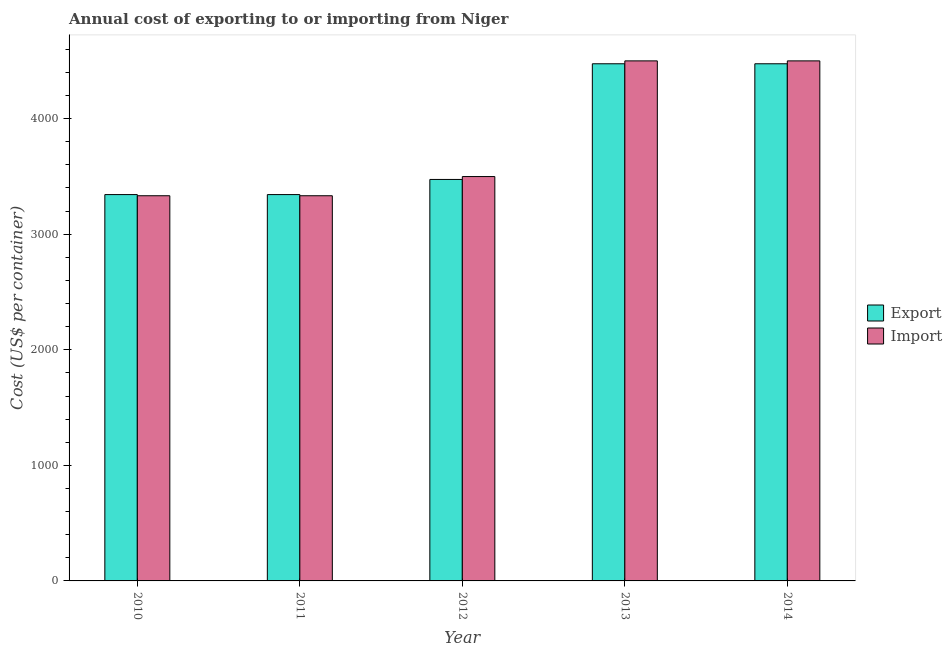How many groups of bars are there?
Provide a short and direct response. 5. How many bars are there on the 4th tick from the left?
Offer a terse response. 2. What is the label of the 5th group of bars from the left?
Your response must be concise. 2014. What is the import cost in 2012?
Offer a very short reply. 3499. Across all years, what is the maximum import cost?
Your answer should be very brief. 4500. Across all years, what is the minimum export cost?
Ensure brevity in your answer.  3343. In which year was the export cost maximum?
Ensure brevity in your answer.  2013. What is the total export cost in the graph?
Your response must be concise. 1.91e+04. What is the difference between the import cost in 2010 and that in 2013?
Provide a succinct answer. -1167. What is the difference between the export cost in 2012 and the import cost in 2011?
Your answer should be compact. 131. What is the average import cost per year?
Give a very brief answer. 3833. What is the ratio of the import cost in 2010 to that in 2014?
Your answer should be very brief. 0.74. Is the export cost in 2010 less than that in 2011?
Give a very brief answer. No. Is the difference between the import cost in 2011 and 2013 greater than the difference between the export cost in 2011 and 2013?
Your answer should be very brief. No. What is the difference between the highest and the lowest export cost?
Your answer should be compact. 1132. Is the sum of the import cost in 2010 and 2014 greater than the maximum export cost across all years?
Your answer should be very brief. Yes. What does the 1st bar from the left in 2010 represents?
Your answer should be very brief. Export. What does the 1st bar from the right in 2013 represents?
Keep it short and to the point. Import. How many bars are there?
Offer a terse response. 10. Are all the bars in the graph horizontal?
Give a very brief answer. No. Are the values on the major ticks of Y-axis written in scientific E-notation?
Provide a short and direct response. No. Does the graph contain any zero values?
Ensure brevity in your answer.  No. Does the graph contain grids?
Your answer should be compact. No. How many legend labels are there?
Your response must be concise. 2. What is the title of the graph?
Your answer should be compact. Annual cost of exporting to or importing from Niger. Does "Current US$" appear as one of the legend labels in the graph?
Ensure brevity in your answer.  No. What is the label or title of the X-axis?
Ensure brevity in your answer.  Year. What is the label or title of the Y-axis?
Provide a succinct answer. Cost (US$ per container). What is the Cost (US$ per container) in Export in 2010?
Give a very brief answer. 3343. What is the Cost (US$ per container) in Import in 2010?
Provide a succinct answer. 3333. What is the Cost (US$ per container) of Export in 2011?
Provide a succinct answer. 3343. What is the Cost (US$ per container) in Import in 2011?
Your answer should be compact. 3333. What is the Cost (US$ per container) of Export in 2012?
Offer a terse response. 3474. What is the Cost (US$ per container) in Import in 2012?
Offer a very short reply. 3499. What is the Cost (US$ per container) in Export in 2013?
Provide a short and direct response. 4475. What is the Cost (US$ per container) of Import in 2013?
Your answer should be very brief. 4500. What is the Cost (US$ per container) in Export in 2014?
Offer a terse response. 4475. What is the Cost (US$ per container) in Import in 2014?
Offer a terse response. 4500. Across all years, what is the maximum Cost (US$ per container) of Export?
Provide a short and direct response. 4475. Across all years, what is the maximum Cost (US$ per container) in Import?
Provide a short and direct response. 4500. Across all years, what is the minimum Cost (US$ per container) of Export?
Make the answer very short. 3343. Across all years, what is the minimum Cost (US$ per container) in Import?
Provide a succinct answer. 3333. What is the total Cost (US$ per container) of Export in the graph?
Keep it short and to the point. 1.91e+04. What is the total Cost (US$ per container) in Import in the graph?
Your answer should be very brief. 1.92e+04. What is the difference between the Cost (US$ per container) of Export in 2010 and that in 2011?
Make the answer very short. 0. What is the difference between the Cost (US$ per container) of Import in 2010 and that in 2011?
Your answer should be very brief. 0. What is the difference between the Cost (US$ per container) of Export in 2010 and that in 2012?
Keep it short and to the point. -131. What is the difference between the Cost (US$ per container) in Import in 2010 and that in 2012?
Provide a short and direct response. -166. What is the difference between the Cost (US$ per container) in Export in 2010 and that in 2013?
Offer a terse response. -1132. What is the difference between the Cost (US$ per container) of Import in 2010 and that in 2013?
Ensure brevity in your answer.  -1167. What is the difference between the Cost (US$ per container) of Export in 2010 and that in 2014?
Offer a terse response. -1132. What is the difference between the Cost (US$ per container) of Import in 2010 and that in 2014?
Your answer should be very brief. -1167. What is the difference between the Cost (US$ per container) of Export in 2011 and that in 2012?
Provide a short and direct response. -131. What is the difference between the Cost (US$ per container) of Import in 2011 and that in 2012?
Your answer should be very brief. -166. What is the difference between the Cost (US$ per container) of Export in 2011 and that in 2013?
Keep it short and to the point. -1132. What is the difference between the Cost (US$ per container) in Import in 2011 and that in 2013?
Your response must be concise. -1167. What is the difference between the Cost (US$ per container) in Export in 2011 and that in 2014?
Offer a very short reply. -1132. What is the difference between the Cost (US$ per container) in Import in 2011 and that in 2014?
Provide a short and direct response. -1167. What is the difference between the Cost (US$ per container) in Export in 2012 and that in 2013?
Offer a very short reply. -1001. What is the difference between the Cost (US$ per container) in Import in 2012 and that in 2013?
Your answer should be very brief. -1001. What is the difference between the Cost (US$ per container) of Export in 2012 and that in 2014?
Your answer should be very brief. -1001. What is the difference between the Cost (US$ per container) of Import in 2012 and that in 2014?
Keep it short and to the point. -1001. What is the difference between the Cost (US$ per container) of Export in 2013 and that in 2014?
Keep it short and to the point. 0. What is the difference between the Cost (US$ per container) in Export in 2010 and the Cost (US$ per container) in Import in 2012?
Your answer should be very brief. -156. What is the difference between the Cost (US$ per container) in Export in 2010 and the Cost (US$ per container) in Import in 2013?
Your answer should be compact. -1157. What is the difference between the Cost (US$ per container) in Export in 2010 and the Cost (US$ per container) in Import in 2014?
Make the answer very short. -1157. What is the difference between the Cost (US$ per container) in Export in 2011 and the Cost (US$ per container) in Import in 2012?
Your answer should be very brief. -156. What is the difference between the Cost (US$ per container) in Export in 2011 and the Cost (US$ per container) in Import in 2013?
Give a very brief answer. -1157. What is the difference between the Cost (US$ per container) in Export in 2011 and the Cost (US$ per container) in Import in 2014?
Ensure brevity in your answer.  -1157. What is the difference between the Cost (US$ per container) of Export in 2012 and the Cost (US$ per container) of Import in 2013?
Your answer should be very brief. -1026. What is the difference between the Cost (US$ per container) in Export in 2012 and the Cost (US$ per container) in Import in 2014?
Your response must be concise. -1026. What is the average Cost (US$ per container) in Export per year?
Your answer should be very brief. 3822. What is the average Cost (US$ per container) in Import per year?
Ensure brevity in your answer.  3833. In the year 2010, what is the difference between the Cost (US$ per container) of Export and Cost (US$ per container) of Import?
Your response must be concise. 10. In the year 2011, what is the difference between the Cost (US$ per container) of Export and Cost (US$ per container) of Import?
Keep it short and to the point. 10. In the year 2014, what is the difference between the Cost (US$ per container) in Export and Cost (US$ per container) in Import?
Your response must be concise. -25. What is the ratio of the Cost (US$ per container) in Export in 2010 to that in 2011?
Give a very brief answer. 1. What is the ratio of the Cost (US$ per container) of Export in 2010 to that in 2012?
Your answer should be compact. 0.96. What is the ratio of the Cost (US$ per container) of Import in 2010 to that in 2012?
Offer a terse response. 0.95. What is the ratio of the Cost (US$ per container) of Export in 2010 to that in 2013?
Offer a terse response. 0.75. What is the ratio of the Cost (US$ per container) in Import in 2010 to that in 2013?
Give a very brief answer. 0.74. What is the ratio of the Cost (US$ per container) in Export in 2010 to that in 2014?
Ensure brevity in your answer.  0.75. What is the ratio of the Cost (US$ per container) in Import in 2010 to that in 2014?
Keep it short and to the point. 0.74. What is the ratio of the Cost (US$ per container) in Export in 2011 to that in 2012?
Provide a short and direct response. 0.96. What is the ratio of the Cost (US$ per container) in Import in 2011 to that in 2012?
Your answer should be compact. 0.95. What is the ratio of the Cost (US$ per container) in Export in 2011 to that in 2013?
Your answer should be compact. 0.75. What is the ratio of the Cost (US$ per container) in Import in 2011 to that in 2013?
Give a very brief answer. 0.74. What is the ratio of the Cost (US$ per container) of Export in 2011 to that in 2014?
Your answer should be very brief. 0.75. What is the ratio of the Cost (US$ per container) in Import in 2011 to that in 2014?
Provide a short and direct response. 0.74. What is the ratio of the Cost (US$ per container) of Export in 2012 to that in 2013?
Offer a very short reply. 0.78. What is the ratio of the Cost (US$ per container) in Import in 2012 to that in 2013?
Offer a very short reply. 0.78. What is the ratio of the Cost (US$ per container) in Export in 2012 to that in 2014?
Provide a short and direct response. 0.78. What is the ratio of the Cost (US$ per container) of Import in 2012 to that in 2014?
Offer a terse response. 0.78. What is the ratio of the Cost (US$ per container) in Export in 2013 to that in 2014?
Your response must be concise. 1. What is the difference between the highest and the second highest Cost (US$ per container) of Export?
Provide a succinct answer. 0. What is the difference between the highest and the second highest Cost (US$ per container) in Import?
Provide a succinct answer. 0. What is the difference between the highest and the lowest Cost (US$ per container) of Export?
Your answer should be compact. 1132. What is the difference between the highest and the lowest Cost (US$ per container) in Import?
Your answer should be compact. 1167. 